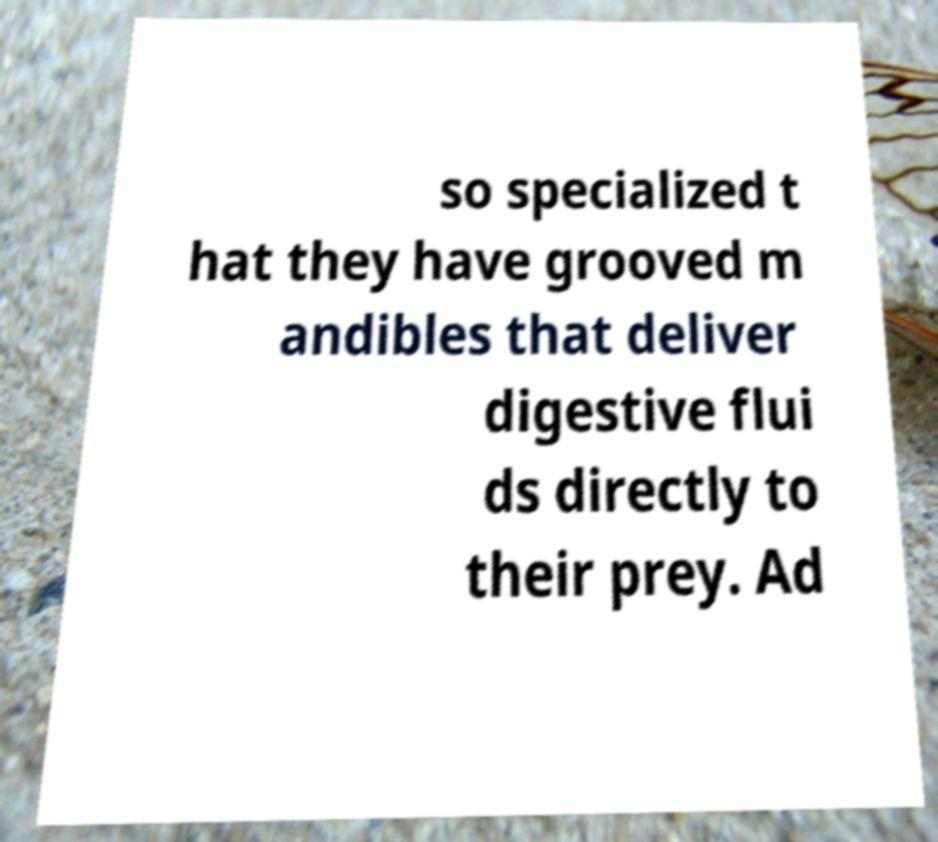Please identify and transcribe the text found in this image. so specialized t hat they have grooved m andibles that deliver digestive flui ds directly to their prey. Ad 